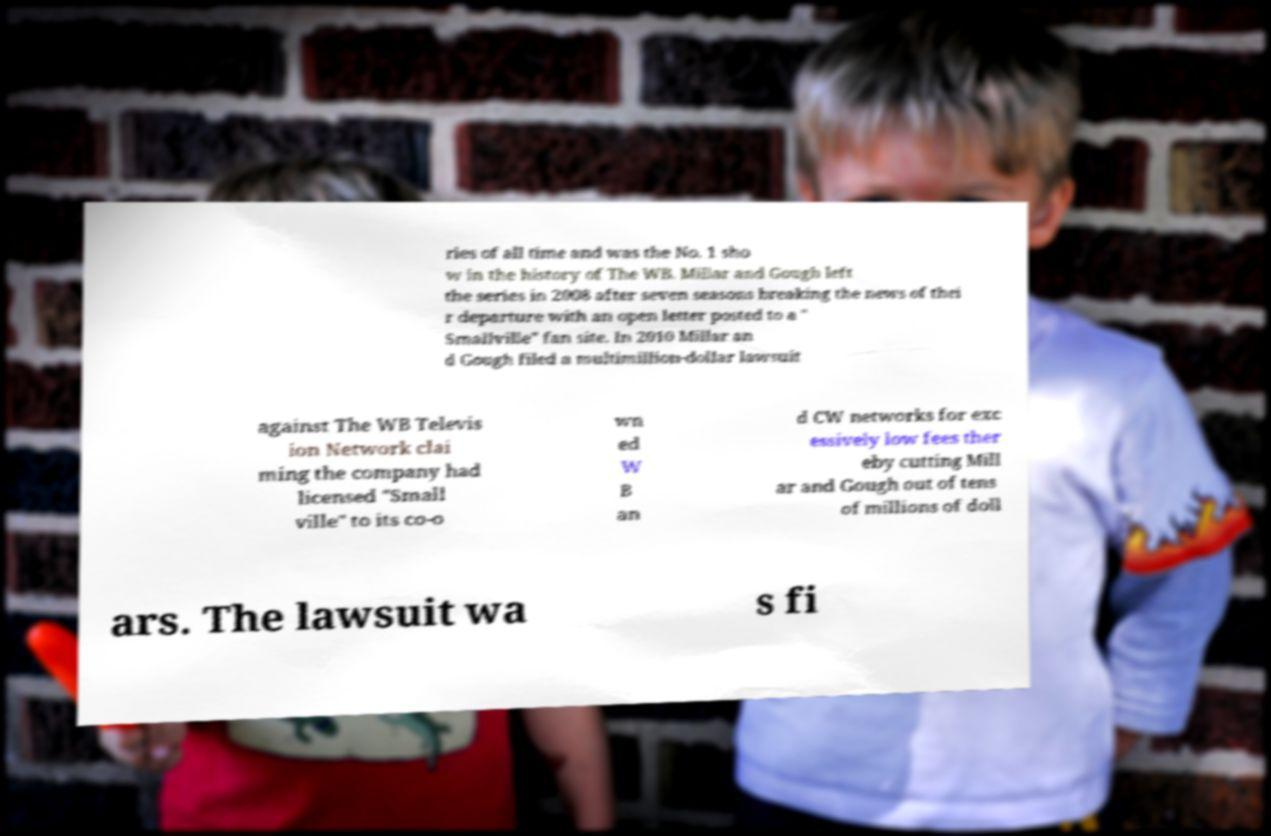Can you read and provide the text displayed in the image?This photo seems to have some interesting text. Can you extract and type it out for me? ries of all time and was the No. 1 sho w in the history of The WB. Millar and Gough left the series in 2008 after seven seasons breaking the news of thei r departure with an open letter posted to a " Smallville" fan site. In 2010 Millar an d Gough filed a multimillion-dollar lawsuit against The WB Televis ion Network clai ming the company had licensed "Small ville" to its co-o wn ed W B an d CW networks for exc essively low fees ther eby cutting Mill ar and Gough out of tens of millions of doll ars. The lawsuit wa s fi 